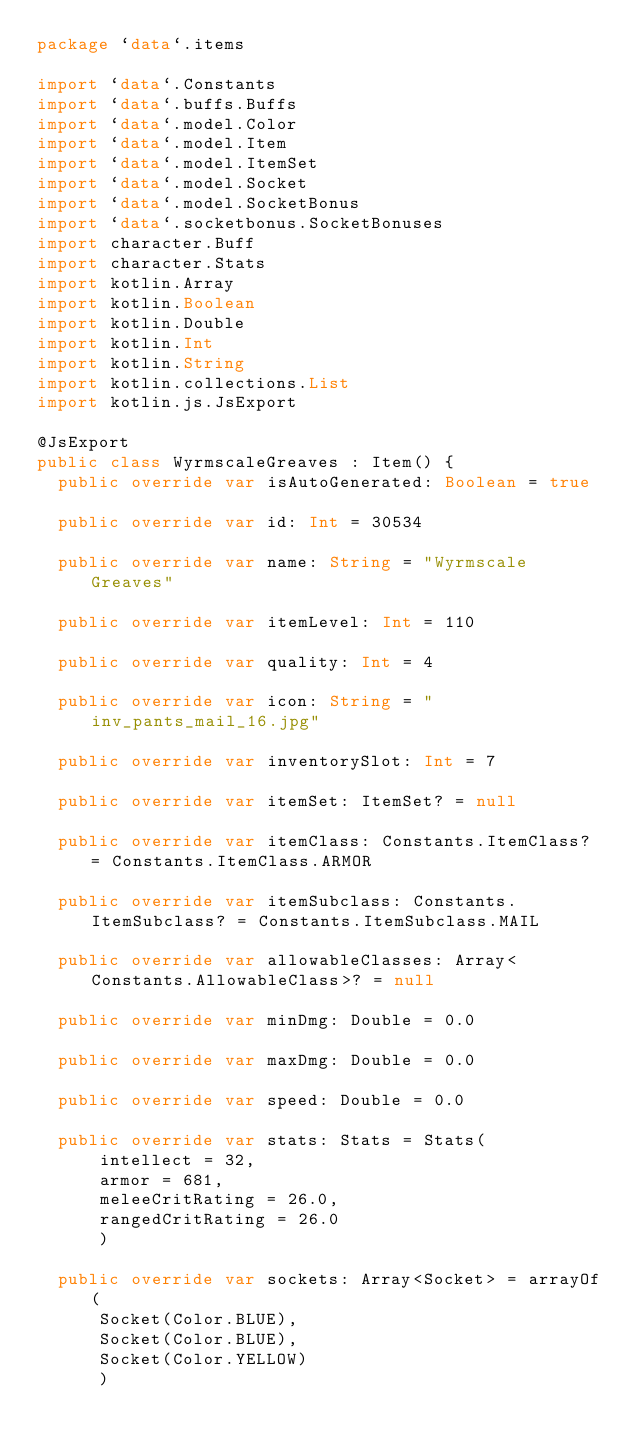Convert code to text. <code><loc_0><loc_0><loc_500><loc_500><_Kotlin_>package `data`.items

import `data`.Constants
import `data`.buffs.Buffs
import `data`.model.Color
import `data`.model.Item
import `data`.model.ItemSet
import `data`.model.Socket
import `data`.model.SocketBonus
import `data`.socketbonus.SocketBonuses
import character.Buff
import character.Stats
import kotlin.Array
import kotlin.Boolean
import kotlin.Double
import kotlin.Int
import kotlin.String
import kotlin.collections.List
import kotlin.js.JsExport

@JsExport
public class WyrmscaleGreaves : Item() {
  public override var isAutoGenerated: Boolean = true

  public override var id: Int = 30534

  public override var name: String = "Wyrmscale Greaves"

  public override var itemLevel: Int = 110

  public override var quality: Int = 4

  public override var icon: String = "inv_pants_mail_16.jpg"

  public override var inventorySlot: Int = 7

  public override var itemSet: ItemSet? = null

  public override var itemClass: Constants.ItemClass? = Constants.ItemClass.ARMOR

  public override var itemSubclass: Constants.ItemSubclass? = Constants.ItemSubclass.MAIL

  public override var allowableClasses: Array<Constants.AllowableClass>? = null

  public override var minDmg: Double = 0.0

  public override var maxDmg: Double = 0.0

  public override var speed: Double = 0.0

  public override var stats: Stats = Stats(
      intellect = 32,
      armor = 681,
      meleeCritRating = 26.0,
      rangedCritRating = 26.0
      )

  public override var sockets: Array<Socket> = arrayOf(
      Socket(Color.BLUE),
      Socket(Color.BLUE),
      Socket(Color.YELLOW)
      )
</code> 